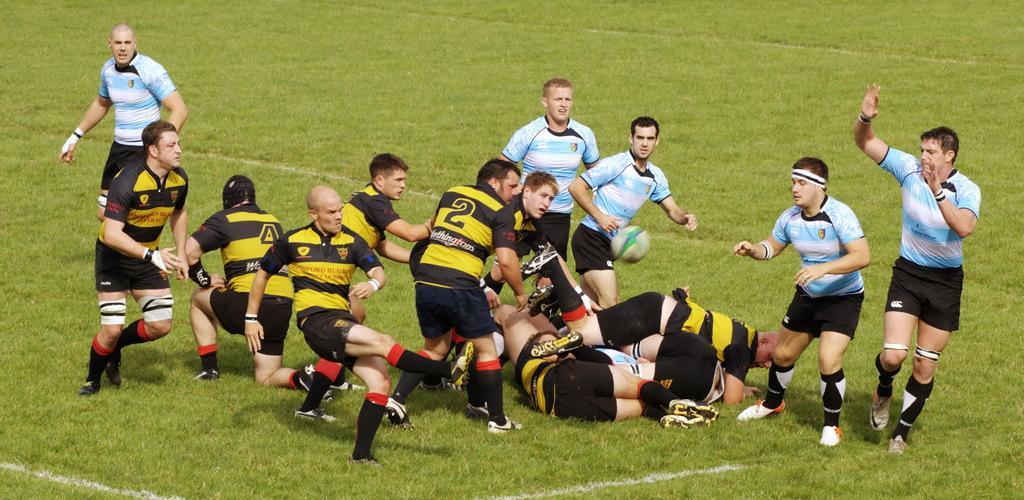How would you summarize this image in a sentence or two? In this picture there are people in the center of the image on the grassland, they are about to catch the ball and there are few people those who are lying on the floor. 